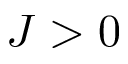Convert formula to latex. <formula><loc_0><loc_0><loc_500><loc_500>J > 0</formula> 